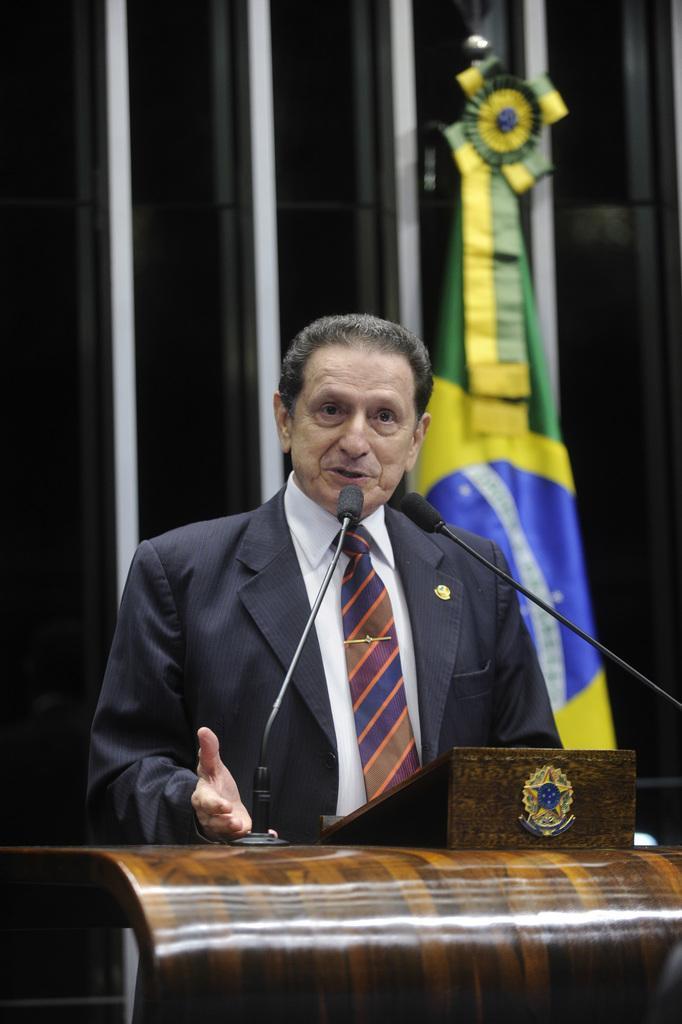In one or two sentences, can you explain what this image depicts? In this image I can see a man is standing in front of a podium. The man is wearing a tie, a shirt and a black color coat. On the podium I can see microphones and other objects. In the background I can see a flag. 